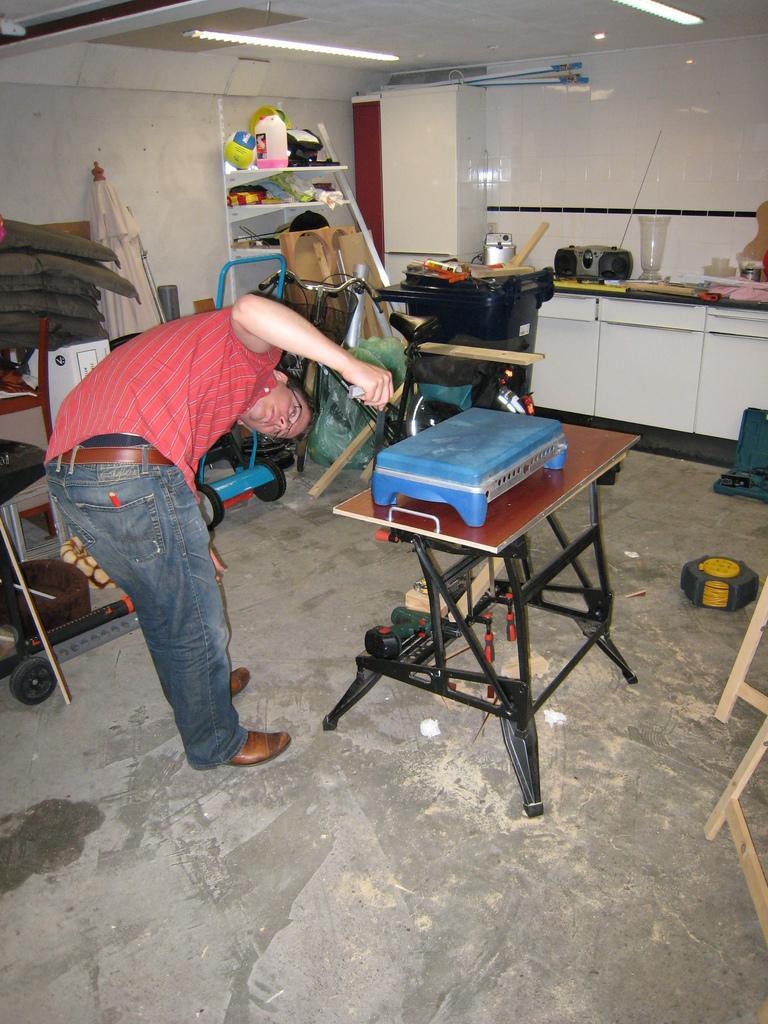Can you describe this image briefly? In this picture we can see a man who is in red color shirt. This is the table. And there is a wall. And these are the lights. 